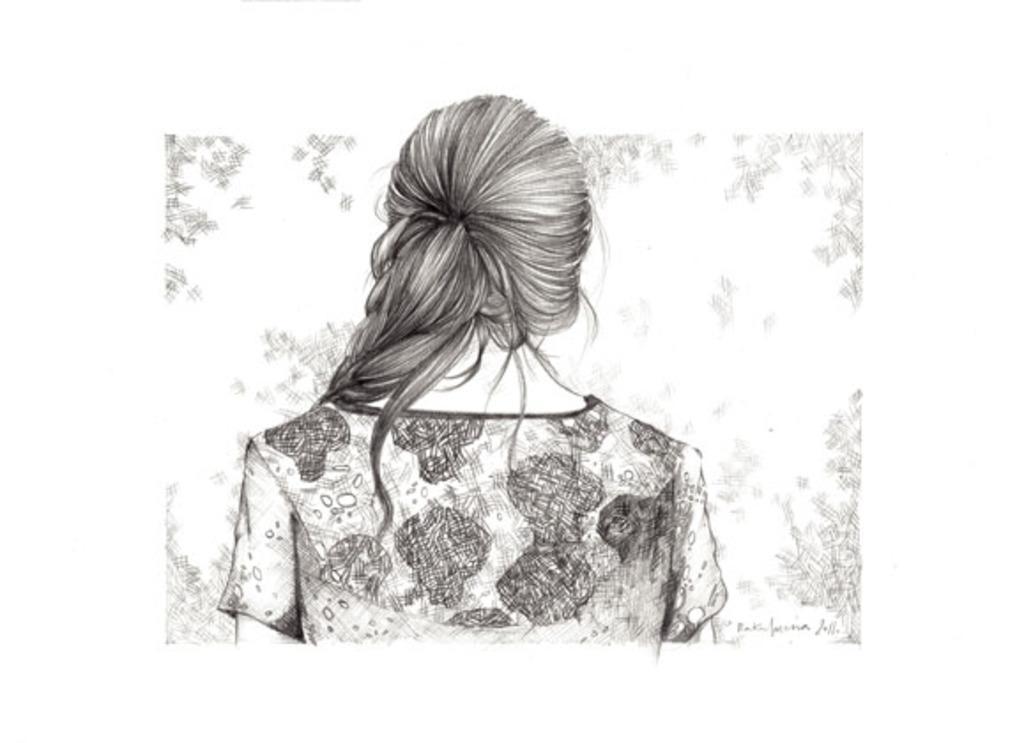How would you summarize this image in a sentence or two? In this image, we can see a sketch contains depiction of a person. 